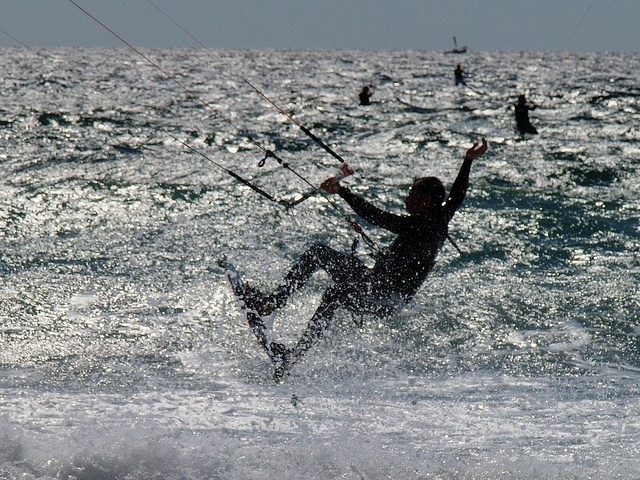Describe the objects in this image and their specific colors. I can see people in gray, black, and darkgray tones, surfboard in gray, darkgray, and black tones, people in gray, black, darkgray, and purple tones, people in gray, black, and darkgray tones, and surfboard in gray, black, and darkgray tones in this image. 